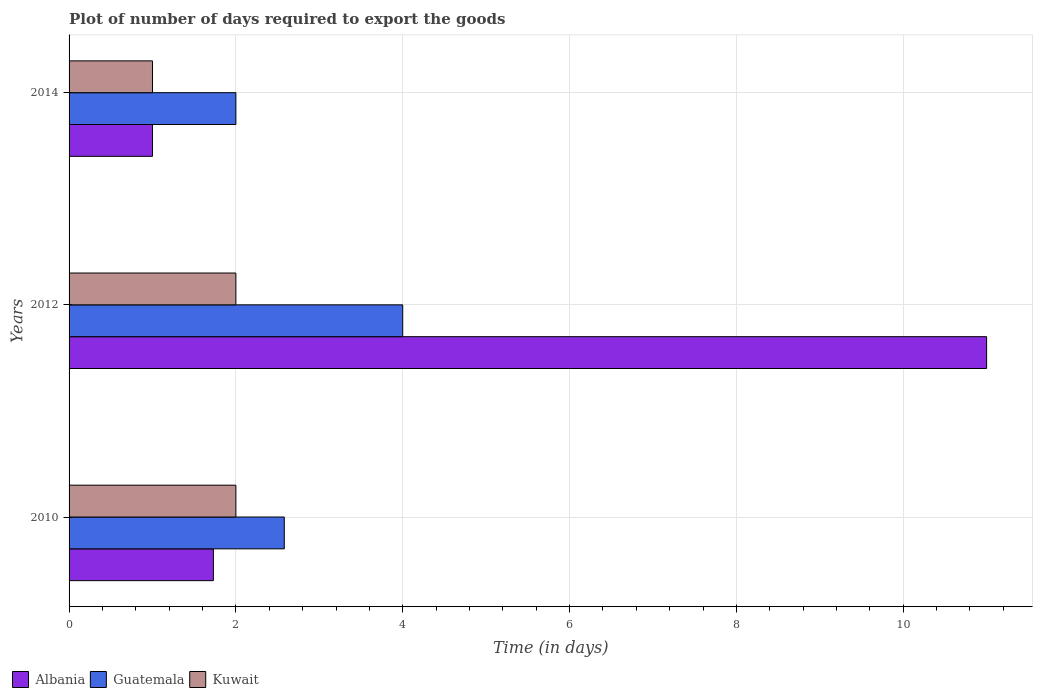How many different coloured bars are there?
Give a very brief answer. 3. How many groups of bars are there?
Give a very brief answer. 3. How many bars are there on the 1st tick from the top?
Ensure brevity in your answer.  3. How many bars are there on the 3rd tick from the bottom?
Keep it short and to the point. 3. What is the label of the 1st group of bars from the top?
Provide a succinct answer. 2014. In how many cases, is the number of bars for a given year not equal to the number of legend labels?
Provide a short and direct response. 0. What is the time required to export goods in Albania in 2010?
Your response must be concise. 1.73. Across all years, what is the maximum time required to export goods in Albania?
Provide a succinct answer. 11. Across all years, what is the minimum time required to export goods in Guatemala?
Your response must be concise. 2. In which year was the time required to export goods in Kuwait maximum?
Your answer should be compact. 2010. In which year was the time required to export goods in Kuwait minimum?
Your answer should be very brief. 2014. What is the difference between the time required to export goods in Guatemala in 2010 and that in 2014?
Give a very brief answer. 0.58. What is the difference between the time required to export goods in Kuwait in 2010 and the time required to export goods in Albania in 2014?
Your answer should be very brief. 1. What is the average time required to export goods in Guatemala per year?
Keep it short and to the point. 2.86. In the year 2010, what is the difference between the time required to export goods in Albania and time required to export goods in Kuwait?
Your answer should be very brief. -0.27. What is the ratio of the time required to export goods in Guatemala in 2010 to that in 2012?
Ensure brevity in your answer.  0.65. Is the time required to export goods in Kuwait in 2012 less than that in 2014?
Offer a terse response. No. What is the difference between the highest and the second highest time required to export goods in Albania?
Keep it short and to the point. 9.27. What is the difference between the highest and the lowest time required to export goods in Guatemala?
Your response must be concise. 2. In how many years, is the time required to export goods in Kuwait greater than the average time required to export goods in Kuwait taken over all years?
Make the answer very short. 2. Is the sum of the time required to export goods in Guatemala in 2010 and 2012 greater than the maximum time required to export goods in Kuwait across all years?
Offer a terse response. Yes. What does the 1st bar from the top in 2012 represents?
Give a very brief answer. Kuwait. What does the 1st bar from the bottom in 2012 represents?
Offer a very short reply. Albania. How many bars are there?
Your answer should be compact. 9. Are all the bars in the graph horizontal?
Give a very brief answer. Yes. How many years are there in the graph?
Give a very brief answer. 3. What is the difference between two consecutive major ticks on the X-axis?
Offer a terse response. 2. Does the graph contain any zero values?
Keep it short and to the point. No. Where does the legend appear in the graph?
Your answer should be compact. Bottom left. What is the title of the graph?
Provide a short and direct response. Plot of number of days required to export the goods. What is the label or title of the X-axis?
Your answer should be compact. Time (in days). What is the Time (in days) in Albania in 2010?
Offer a very short reply. 1.73. What is the Time (in days) of Guatemala in 2010?
Give a very brief answer. 2.58. What is the Time (in days) in Kuwait in 2010?
Keep it short and to the point. 2. What is the Time (in days) of Guatemala in 2014?
Your answer should be very brief. 2. Across all years, what is the maximum Time (in days) of Albania?
Your answer should be compact. 11. Across all years, what is the maximum Time (in days) of Kuwait?
Provide a short and direct response. 2. Across all years, what is the minimum Time (in days) in Albania?
Ensure brevity in your answer.  1. What is the total Time (in days) of Albania in the graph?
Give a very brief answer. 13.73. What is the total Time (in days) in Guatemala in the graph?
Make the answer very short. 8.58. What is the total Time (in days) of Kuwait in the graph?
Your answer should be very brief. 5. What is the difference between the Time (in days) of Albania in 2010 and that in 2012?
Provide a short and direct response. -9.27. What is the difference between the Time (in days) of Guatemala in 2010 and that in 2012?
Your answer should be compact. -1.42. What is the difference between the Time (in days) in Albania in 2010 and that in 2014?
Offer a terse response. 0.73. What is the difference between the Time (in days) in Guatemala in 2010 and that in 2014?
Your answer should be compact. 0.58. What is the difference between the Time (in days) of Guatemala in 2012 and that in 2014?
Make the answer very short. 2. What is the difference between the Time (in days) of Albania in 2010 and the Time (in days) of Guatemala in 2012?
Offer a very short reply. -2.27. What is the difference between the Time (in days) of Albania in 2010 and the Time (in days) of Kuwait in 2012?
Your answer should be very brief. -0.27. What is the difference between the Time (in days) of Guatemala in 2010 and the Time (in days) of Kuwait in 2012?
Your answer should be very brief. 0.58. What is the difference between the Time (in days) in Albania in 2010 and the Time (in days) in Guatemala in 2014?
Your response must be concise. -0.27. What is the difference between the Time (in days) in Albania in 2010 and the Time (in days) in Kuwait in 2014?
Keep it short and to the point. 0.73. What is the difference between the Time (in days) of Guatemala in 2010 and the Time (in days) of Kuwait in 2014?
Offer a terse response. 1.58. What is the difference between the Time (in days) in Albania in 2012 and the Time (in days) in Guatemala in 2014?
Your response must be concise. 9. What is the difference between the Time (in days) in Albania in 2012 and the Time (in days) in Kuwait in 2014?
Give a very brief answer. 10. What is the average Time (in days) of Albania per year?
Ensure brevity in your answer.  4.58. What is the average Time (in days) in Guatemala per year?
Provide a short and direct response. 2.86. What is the average Time (in days) in Kuwait per year?
Provide a succinct answer. 1.67. In the year 2010, what is the difference between the Time (in days) in Albania and Time (in days) in Guatemala?
Your answer should be compact. -0.85. In the year 2010, what is the difference between the Time (in days) in Albania and Time (in days) in Kuwait?
Give a very brief answer. -0.27. In the year 2010, what is the difference between the Time (in days) in Guatemala and Time (in days) in Kuwait?
Ensure brevity in your answer.  0.58. In the year 2014, what is the difference between the Time (in days) in Guatemala and Time (in days) in Kuwait?
Provide a succinct answer. 1. What is the ratio of the Time (in days) of Albania in 2010 to that in 2012?
Offer a terse response. 0.16. What is the ratio of the Time (in days) in Guatemala in 2010 to that in 2012?
Offer a very short reply. 0.65. What is the ratio of the Time (in days) of Kuwait in 2010 to that in 2012?
Offer a very short reply. 1. What is the ratio of the Time (in days) of Albania in 2010 to that in 2014?
Offer a very short reply. 1.73. What is the ratio of the Time (in days) of Guatemala in 2010 to that in 2014?
Make the answer very short. 1.29. What is the ratio of the Time (in days) in Kuwait in 2010 to that in 2014?
Give a very brief answer. 2. What is the difference between the highest and the second highest Time (in days) in Albania?
Ensure brevity in your answer.  9.27. What is the difference between the highest and the second highest Time (in days) in Guatemala?
Make the answer very short. 1.42. What is the difference between the highest and the lowest Time (in days) of Albania?
Offer a very short reply. 10. What is the difference between the highest and the lowest Time (in days) of Kuwait?
Your response must be concise. 1. 